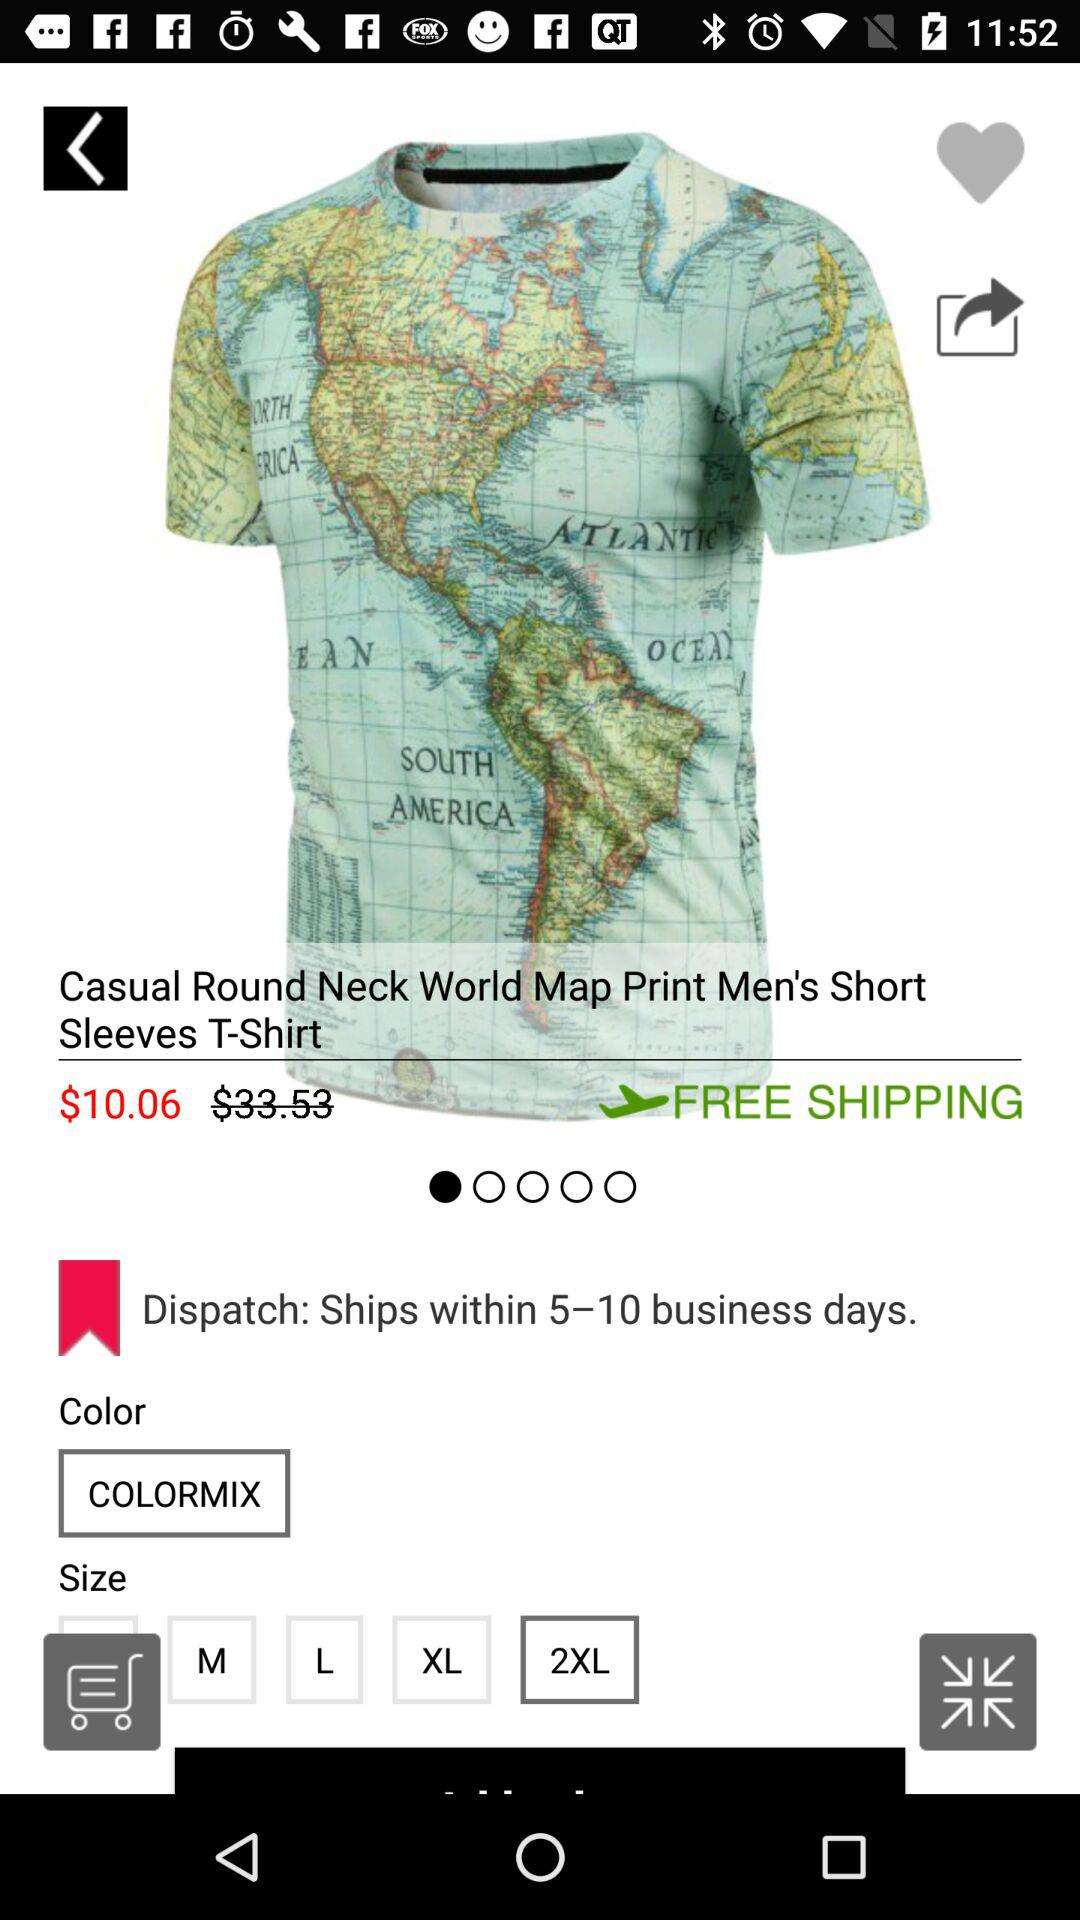How many sizes are available?
Answer the question using a single word or phrase. 5 